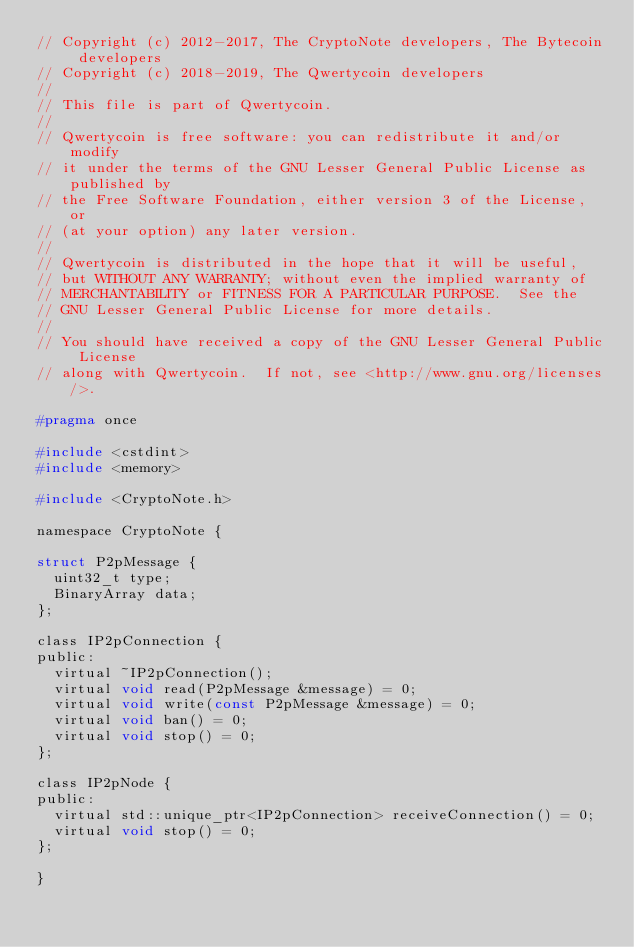<code> <loc_0><loc_0><loc_500><loc_500><_C_>// Copyright (c) 2012-2017, The CryptoNote developers, The Bytecoin developers
// Copyright (c) 2018-2019, The Qwertycoin developers
//
// This file is part of Qwertycoin.
//
// Qwertycoin is free software: you can redistribute it and/or modify
// it under the terms of the GNU Lesser General Public License as published by
// the Free Software Foundation, either version 3 of the License, or
// (at your option) any later version.
//
// Qwertycoin is distributed in the hope that it will be useful,
// but WITHOUT ANY WARRANTY; without even the implied warranty of
// MERCHANTABILITY or FITNESS FOR A PARTICULAR PURPOSE.  See the
// GNU Lesser General Public License for more details.
//
// You should have received a copy of the GNU Lesser General Public License
// along with Qwertycoin.  If not, see <http://www.gnu.org/licenses/>.

#pragma once

#include <cstdint>
#include <memory>

#include <CryptoNote.h>

namespace CryptoNote {

struct P2pMessage {
  uint32_t type;
  BinaryArray data;
};

class IP2pConnection {
public:
  virtual ~IP2pConnection();
  virtual void read(P2pMessage &message) = 0;
  virtual void write(const P2pMessage &message) = 0;
  virtual void ban() = 0;
  virtual void stop() = 0;
};

class IP2pNode {
public:
  virtual std::unique_ptr<IP2pConnection> receiveConnection() = 0;
  virtual void stop() = 0;
};

}
</code> 